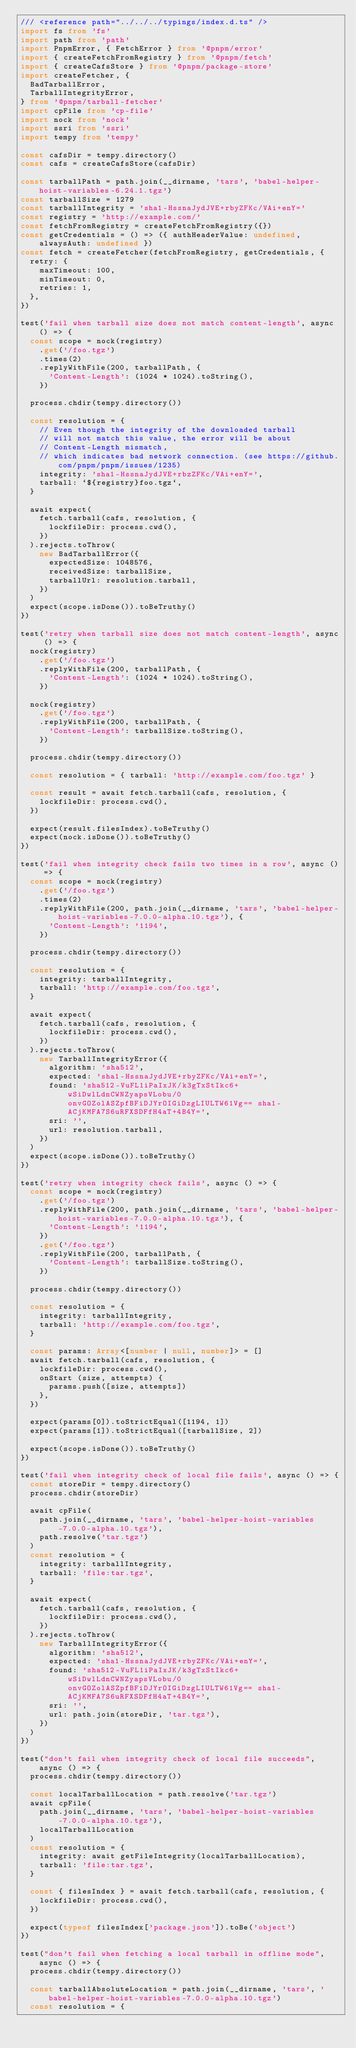Convert code to text. <code><loc_0><loc_0><loc_500><loc_500><_TypeScript_>/// <reference path="../../../typings/index.d.ts" />
import fs from 'fs'
import path from 'path'
import PnpmError, { FetchError } from '@pnpm/error'
import { createFetchFromRegistry } from '@pnpm/fetch'
import { createCafsStore } from '@pnpm/package-store'
import createFetcher, {
  BadTarballError,
  TarballIntegrityError,
} from '@pnpm/tarball-fetcher'
import cpFile from 'cp-file'
import nock from 'nock'
import ssri from 'ssri'
import tempy from 'tempy'

const cafsDir = tempy.directory()
const cafs = createCafsStore(cafsDir)

const tarballPath = path.join(__dirname, 'tars', 'babel-helper-hoist-variables-6.24.1.tgz')
const tarballSize = 1279
const tarballIntegrity = 'sha1-HssnaJydJVE+rbyZFKc/VAi+enY='
const registry = 'http://example.com/'
const fetchFromRegistry = createFetchFromRegistry({})
const getCredentials = () => ({ authHeaderValue: undefined, alwaysAuth: undefined })
const fetch = createFetcher(fetchFromRegistry, getCredentials, {
  retry: {
    maxTimeout: 100,
    minTimeout: 0,
    retries: 1,
  },
})

test('fail when tarball size does not match content-length', async () => {
  const scope = nock(registry)
    .get('/foo.tgz')
    .times(2)
    .replyWithFile(200, tarballPath, {
      'Content-Length': (1024 * 1024).toString(),
    })

  process.chdir(tempy.directory())

  const resolution = {
    // Even though the integrity of the downloaded tarball
    // will not match this value, the error will be about
    // Content-Length mismatch,
    // which indicates bad network connection. (see https://github.com/pnpm/pnpm/issues/1235)
    integrity: 'sha1-HssnaJydJVE+rbzZFKc/VAi+enY=',
    tarball: `${registry}foo.tgz`,
  }

  await expect(
    fetch.tarball(cafs, resolution, {
      lockfileDir: process.cwd(),
    })
  ).rejects.toThrow(
    new BadTarballError({
      expectedSize: 1048576,
      receivedSize: tarballSize,
      tarballUrl: resolution.tarball,
    })
  )
  expect(scope.isDone()).toBeTruthy()
})

test('retry when tarball size does not match content-length', async () => {
  nock(registry)
    .get('/foo.tgz')
    .replyWithFile(200, tarballPath, {
      'Content-Length': (1024 * 1024).toString(),
    })

  nock(registry)
    .get('/foo.tgz')
    .replyWithFile(200, tarballPath, {
      'Content-Length': tarballSize.toString(),
    })

  process.chdir(tempy.directory())

  const resolution = { tarball: 'http://example.com/foo.tgz' }

  const result = await fetch.tarball(cafs, resolution, {
    lockfileDir: process.cwd(),
  })

  expect(result.filesIndex).toBeTruthy()
  expect(nock.isDone()).toBeTruthy()
})

test('fail when integrity check fails two times in a row', async () => {
  const scope = nock(registry)
    .get('/foo.tgz')
    .times(2)
    .replyWithFile(200, path.join(__dirname, 'tars', 'babel-helper-hoist-variables-7.0.0-alpha.10.tgz'), {
      'Content-Length': '1194',
    })

  process.chdir(tempy.directory())

  const resolution = {
    integrity: tarballIntegrity,
    tarball: 'http://example.com/foo.tgz',
  }

  await expect(
    fetch.tarball(cafs, resolution, {
      lockfileDir: process.cwd(),
    })
  ).rejects.toThrow(
    new TarballIntegrityError({
      algorithm: 'sha512',
      expected: 'sha1-HssnaJydJVE+rbyZFKc/VAi+enY=',
      found: 'sha512-VuFL1iPaIxJK/k3gTxStIkc6+wSiDwlLdnCWNZyapsVLobu/0onvGOZolASZpfBFiDJYrOIGiDzgLIULTW61Vg== sha1-ACjKMFA7S6uRFXSDFfH4aT+4B4Y=',
      sri: '',
      url: resolution.tarball,
    })
  )
  expect(scope.isDone()).toBeTruthy()
})

test('retry when integrity check fails', async () => {
  const scope = nock(registry)
    .get('/foo.tgz')
    .replyWithFile(200, path.join(__dirname, 'tars', 'babel-helper-hoist-variables-7.0.0-alpha.10.tgz'), {
      'Content-Length': '1194',
    })
    .get('/foo.tgz')
    .replyWithFile(200, tarballPath, {
      'Content-Length': tarballSize.toString(),
    })

  process.chdir(tempy.directory())

  const resolution = {
    integrity: tarballIntegrity,
    tarball: 'http://example.com/foo.tgz',
  }

  const params: Array<[number | null, number]> = []
  await fetch.tarball(cafs, resolution, {
    lockfileDir: process.cwd(),
    onStart (size, attempts) {
      params.push([size, attempts])
    },
  })

  expect(params[0]).toStrictEqual([1194, 1])
  expect(params[1]).toStrictEqual([tarballSize, 2])

  expect(scope.isDone()).toBeTruthy()
})

test('fail when integrity check of local file fails', async () => {
  const storeDir = tempy.directory()
  process.chdir(storeDir)

  await cpFile(
    path.join(__dirname, 'tars', 'babel-helper-hoist-variables-7.0.0-alpha.10.tgz'),
    path.resolve('tar.tgz')
  )
  const resolution = {
    integrity: tarballIntegrity,
    tarball: 'file:tar.tgz',
  }

  await expect(
    fetch.tarball(cafs, resolution, {
      lockfileDir: process.cwd(),
    })
  ).rejects.toThrow(
    new TarballIntegrityError({
      algorithm: 'sha512',
      expected: 'sha1-HssnaJydJVE+rbyZFKc/VAi+enY=',
      found: 'sha512-VuFL1iPaIxJK/k3gTxStIkc6+wSiDwlLdnCWNZyapsVLobu/0onvGOZolASZpfBFiDJYrOIGiDzgLIULTW61Vg== sha1-ACjKMFA7S6uRFXSDFfH4aT+4B4Y=',
      sri: '',
      url: path.join(storeDir, 'tar.tgz'),
    })
  )
})

test("don't fail when integrity check of local file succeeds", async () => {
  process.chdir(tempy.directory())

  const localTarballLocation = path.resolve('tar.tgz')
  await cpFile(
    path.join(__dirname, 'tars', 'babel-helper-hoist-variables-7.0.0-alpha.10.tgz'),
    localTarballLocation
  )
  const resolution = {
    integrity: await getFileIntegrity(localTarballLocation),
    tarball: 'file:tar.tgz',
  }

  const { filesIndex } = await fetch.tarball(cafs, resolution, {
    lockfileDir: process.cwd(),
  })

  expect(typeof filesIndex['package.json']).toBe('object')
})

test("don't fail when fetching a local tarball in offline mode", async () => {
  process.chdir(tempy.directory())

  const tarballAbsoluteLocation = path.join(__dirname, 'tars', 'babel-helper-hoist-variables-7.0.0-alpha.10.tgz')
  const resolution = {</code> 